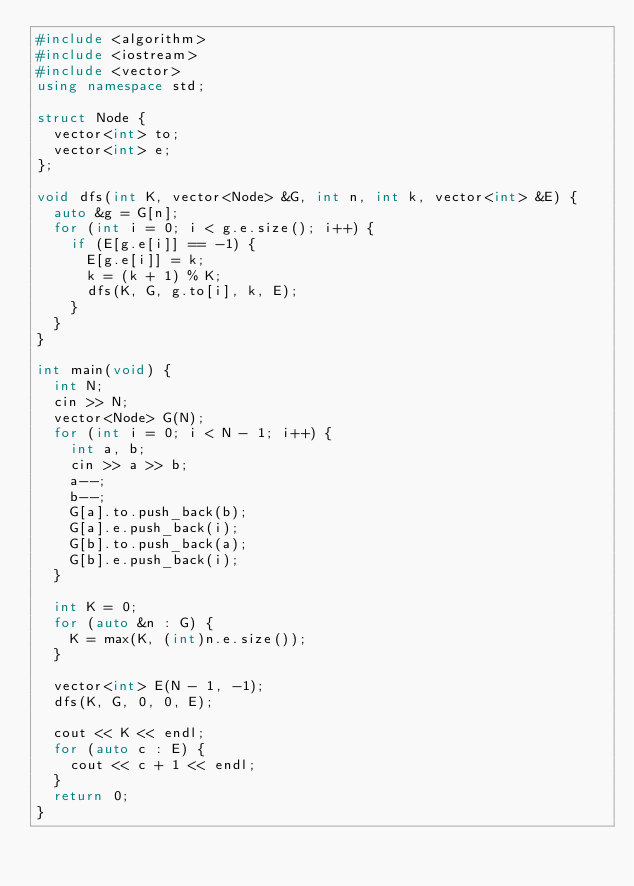Convert code to text. <code><loc_0><loc_0><loc_500><loc_500><_C++_>#include <algorithm>
#include <iostream>
#include <vector>
using namespace std;

struct Node {
  vector<int> to;
  vector<int> e;
};

void dfs(int K, vector<Node> &G, int n, int k, vector<int> &E) {
  auto &g = G[n];
  for (int i = 0; i < g.e.size(); i++) {
    if (E[g.e[i]] == -1) {
      E[g.e[i]] = k;
      k = (k + 1) % K;
      dfs(K, G, g.to[i], k, E);
    }
  }
}

int main(void) {
  int N;
  cin >> N;
  vector<Node> G(N);
  for (int i = 0; i < N - 1; i++) {
    int a, b;
    cin >> a >> b;
    a--;
    b--;
    G[a].to.push_back(b);
    G[a].e.push_back(i);
    G[b].to.push_back(a);
    G[b].e.push_back(i);
  }

  int K = 0;
  for (auto &n : G) {
    K = max(K, (int)n.e.size());
  }

  vector<int> E(N - 1, -1);
  dfs(K, G, 0, 0, E);

  cout << K << endl;
  for (auto c : E) {
    cout << c + 1 << endl;
  }
  return 0;
}</code> 